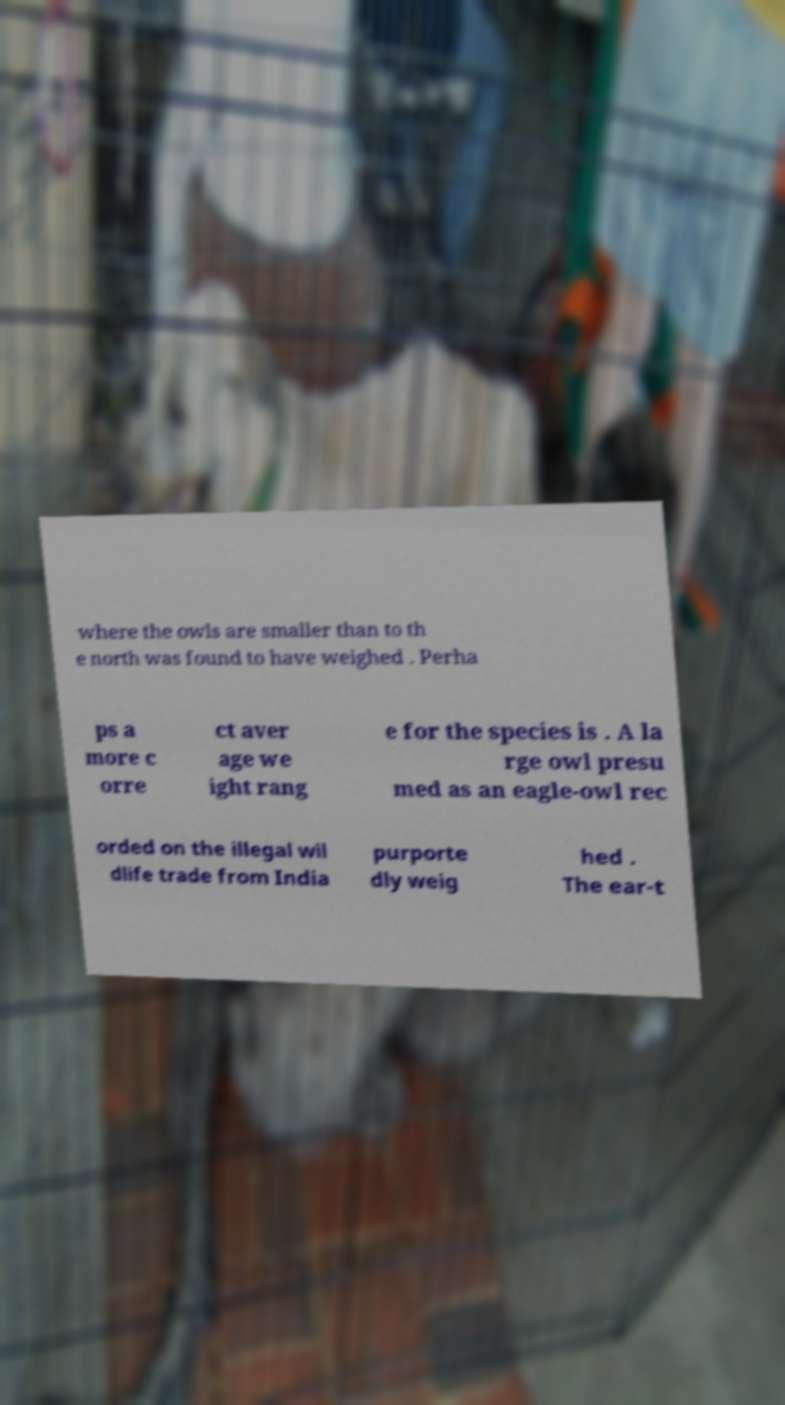Can you accurately transcribe the text from the provided image for me? where the owls are smaller than to th e north was found to have weighed . Perha ps a more c orre ct aver age we ight rang e for the species is . A la rge owl presu med as an eagle-owl rec orded on the illegal wil dlife trade from India purporte dly weig hed . The ear-t 